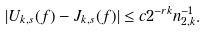Convert formula to latex. <formula><loc_0><loc_0><loc_500><loc_500>| U _ { k , s } ( f ) - J _ { k , s } ( f ) | \leq c 2 ^ { - r k } n _ { 2 , k } ^ { - 1 } .</formula> 